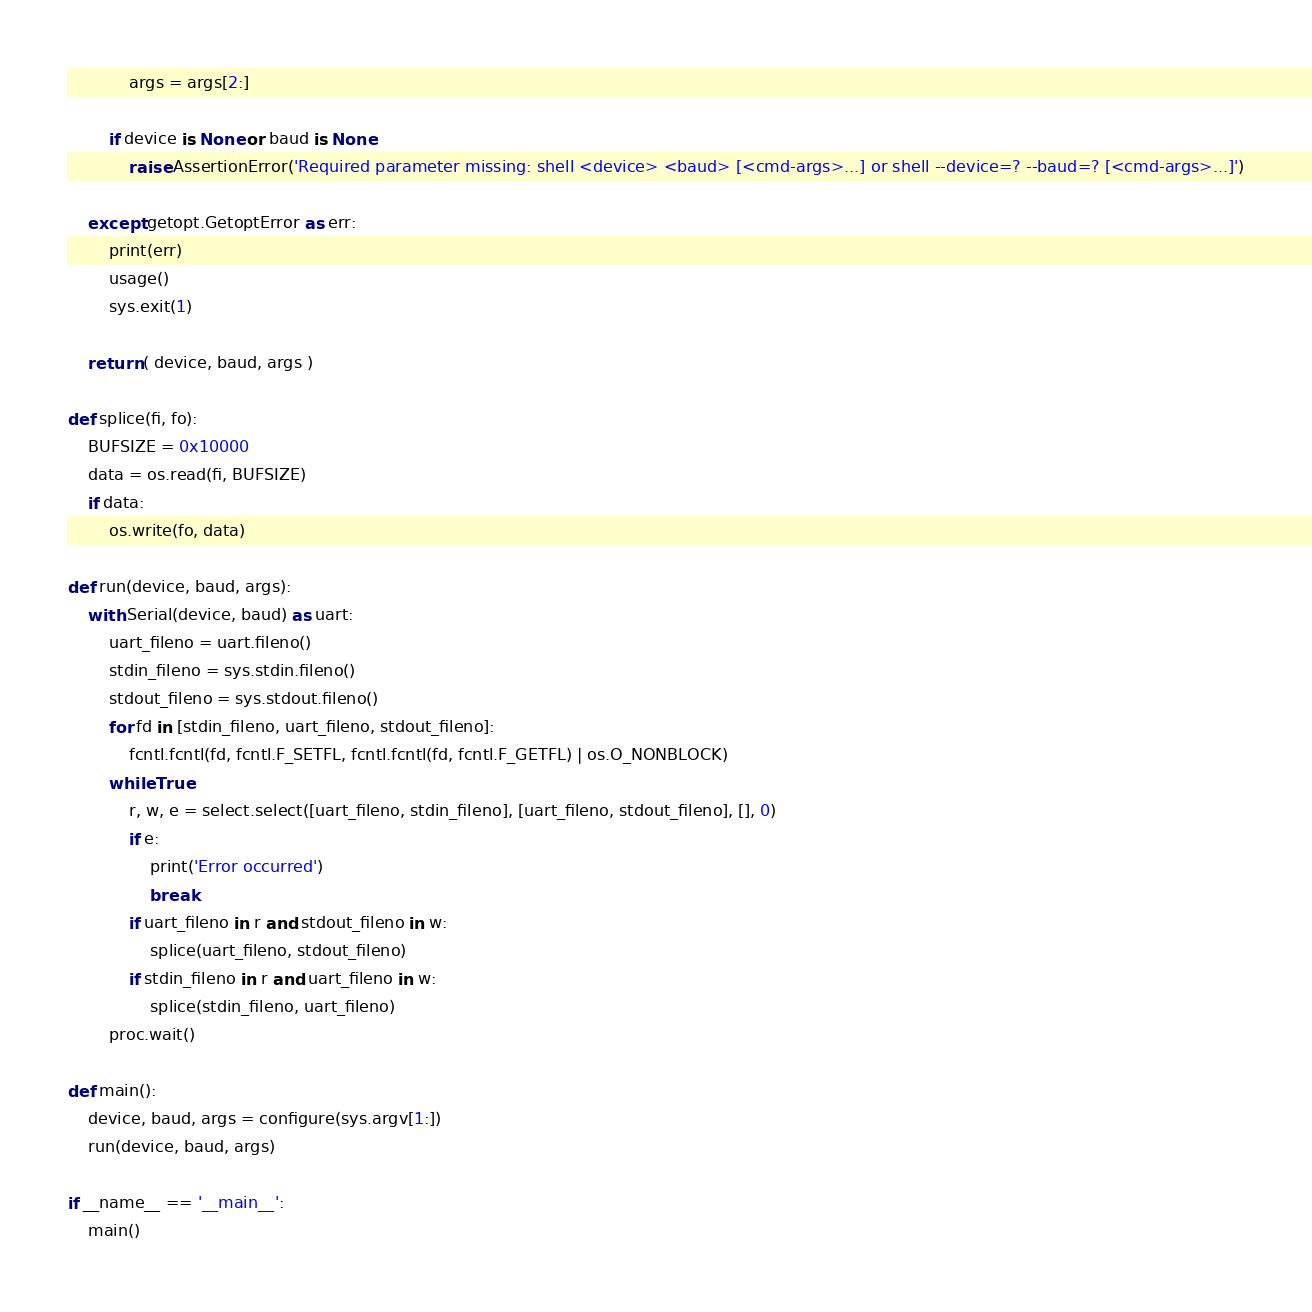Convert code to text. <code><loc_0><loc_0><loc_500><loc_500><_Python_>			args = args[2:]

		if device is None or baud is None:
			raise AssertionError('Required parameter missing: shell <device> <baud> [<cmd-args>...] or shell --device=? --baud=? [<cmd-args>...]')

	except getopt.GetoptError as err:
		print(err)
		usage()
		sys.exit(1)

	return ( device, baud, args )

def splice(fi, fo):
	BUFSIZE = 0x10000
	data = os.read(fi, BUFSIZE)
	if data:
		os.write(fo, data)

def run(device, baud, args):
	with Serial(device, baud) as uart:
		uart_fileno = uart.fileno()
		stdin_fileno = sys.stdin.fileno()
		stdout_fileno = sys.stdout.fileno()
		for fd in [stdin_fileno, uart_fileno, stdout_fileno]:
			fcntl.fcntl(fd, fcntl.F_SETFL, fcntl.fcntl(fd, fcntl.F_GETFL) | os.O_NONBLOCK)
		while True:
			r, w, e = select.select([uart_fileno, stdin_fileno], [uart_fileno, stdout_fileno], [], 0)
			if e:
				print('Error occurred')
				break
			if uart_fileno in r and stdout_fileno in w:
				splice(uart_fileno, stdout_fileno)
			if stdin_fileno in r and uart_fileno in w:
				splice(stdin_fileno, uart_fileno)
		proc.wait()

def main():
	device, baud, args = configure(sys.argv[1:])
	run(device, baud, args)

if __name__ == '__main__':
	main()
</code> 